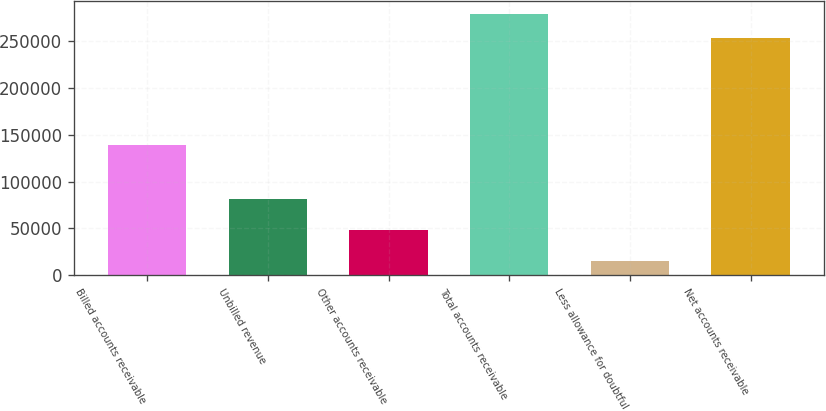Convert chart to OTSL. <chart><loc_0><loc_0><loc_500><loc_500><bar_chart><fcel>Billed accounts receivable<fcel>Unbilled revenue<fcel>Other accounts receivable<fcel>Total accounts receivable<fcel>Less allowance for doubtful<fcel>Net accounts receivable<nl><fcel>138794<fcel>81005<fcel>48291<fcel>278624<fcel>14795<fcel>253295<nl></chart> 